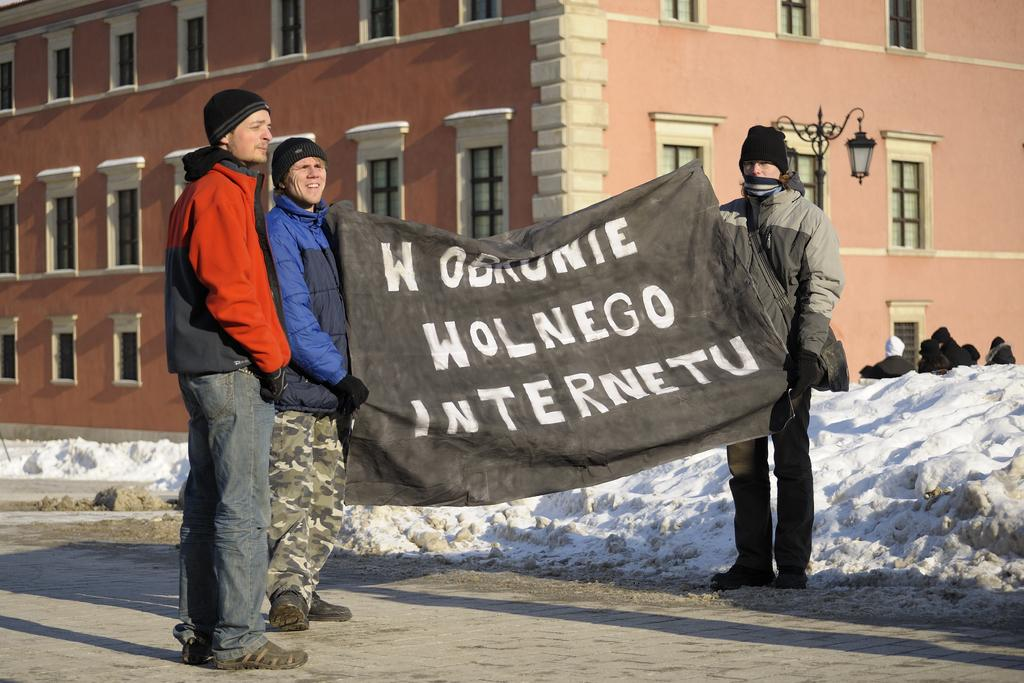What type of structures can be seen in the image? There are buildings in the image. What is the source of light visible in the image? There is a street lamp in the image. What are the three people in the image doing? They are holding a banner in the image. What is the weather condition in the image? There is snow visible in the image. How many horses are visible in the image? There are no horses present in the image. Are there any dinosaurs visible in the image? There are no dinosaurs present in the image. 